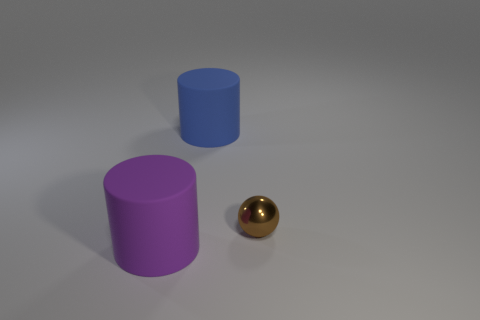How many other small spheres are the same color as the small metallic ball?
Your answer should be compact. 0. What number of small objects are blue cubes or purple rubber things?
Your response must be concise. 0. Are there any other big things that have the same shape as the big purple thing?
Your response must be concise. Yes. Is the shape of the big blue rubber thing the same as the purple matte thing?
Ensure brevity in your answer.  Yes. What is the color of the rubber cylinder that is behind the big purple thing left of the tiny brown metal ball?
Offer a terse response. Blue. The other object that is the same size as the blue object is what color?
Give a very brief answer. Purple. How many rubber things are either small brown spheres or large purple things?
Your answer should be compact. 1. How many big rubber cylinders are behind the large cylinder that is left of the blue cylinder?
Provide a short and direct response. 1. How many objects are large blue rubber cylinders or things that are in front of the big blue thing?
Provide a short and direct response. 3. Are there any big purple objects made of the same material as the blue cylinder?
Provide a succinct answer. Yes. 